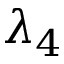<formula> <loc_0><loc_0><loc_500><loc_500>\lambda _ { 4 }</formula> 